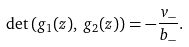Convert formula to latex. <formula><loc_0><loc_0><loc_500><loc_500>\det \left ( g _ { 1 } ( z ) , \, g _ { 2 } ( z ) \right ) = - \frac { v _ { - } } { b _ { - } } .</formula> 